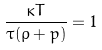Convert formula to latex. <formula><loc_0><loc_0><loc_500><loc_500>\frac { \kappa T } { \tau ( \rho + p ) } = 1</formula> 